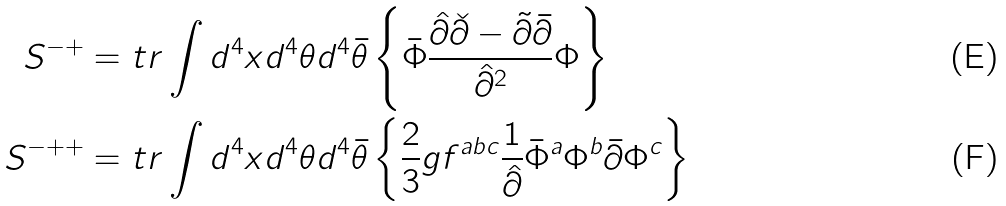<formula> <loc_0><loc_0><loc_500><loc_500>S ^ { - + } & = t r \int d ^ { 4 } x d ^ { 4 } \theta d ^ { 4 } \bar { \theta } \left \{ \bar { \Phi } \frac { \hat { \partial } \check { \partial } - \tilde { \partial } \bar { \partial } } { \hat { \partial } ^ { 2 } } \Phi \right \} \\ S ^ { - + + } & = t r \int d ^ { 4 } x d ^ { 4 } \theta d ^ { 4 } \bar { \theta } \left \{ \frac { 2 } { 3 } g f ^ { a b c } \frac { 1 } { \hat { \partial } } \bar { \Phi } ^ { a } \Phi ^ { b } \bar { \partial } \Phi ^ { c } \right \}</formula> 